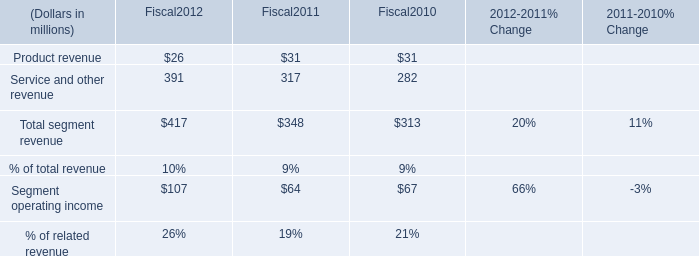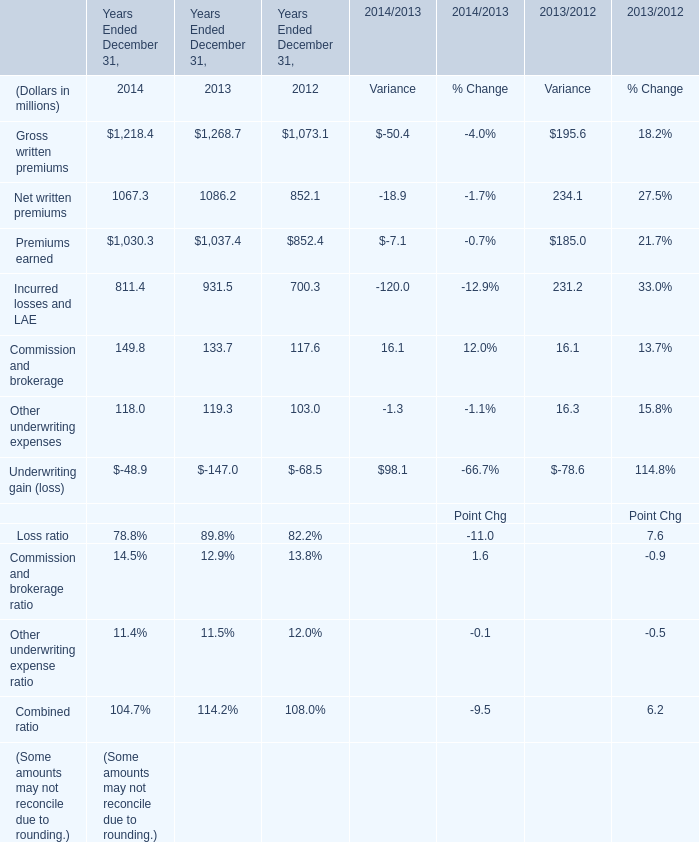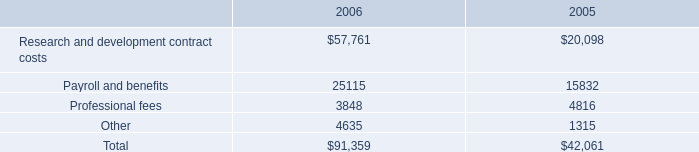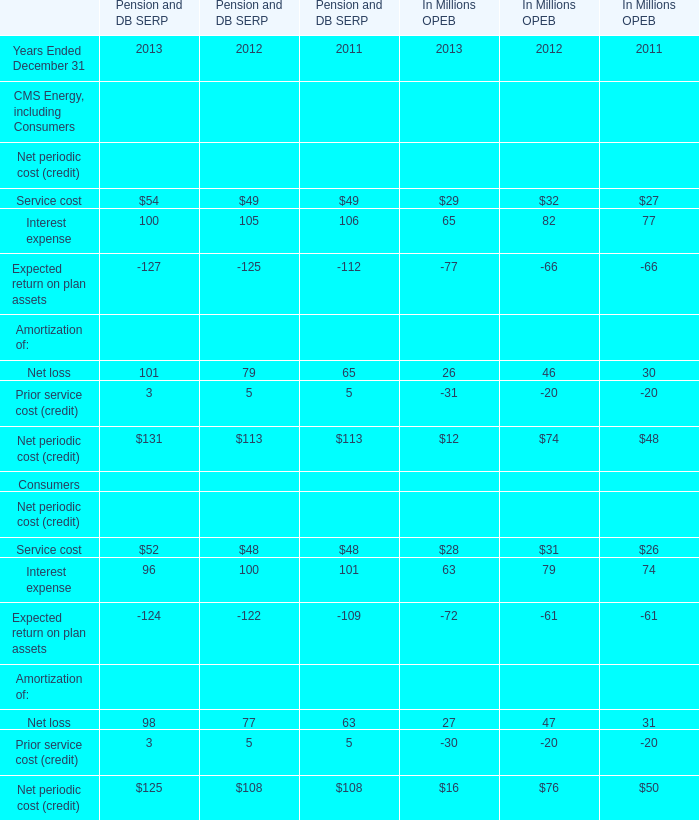in 2006 what was the percent of the recorded an unrealized gain on the fair market value of the altus warrants\\n 
Computations: (4.3 / 19.1)
Answer: 0.22513. 